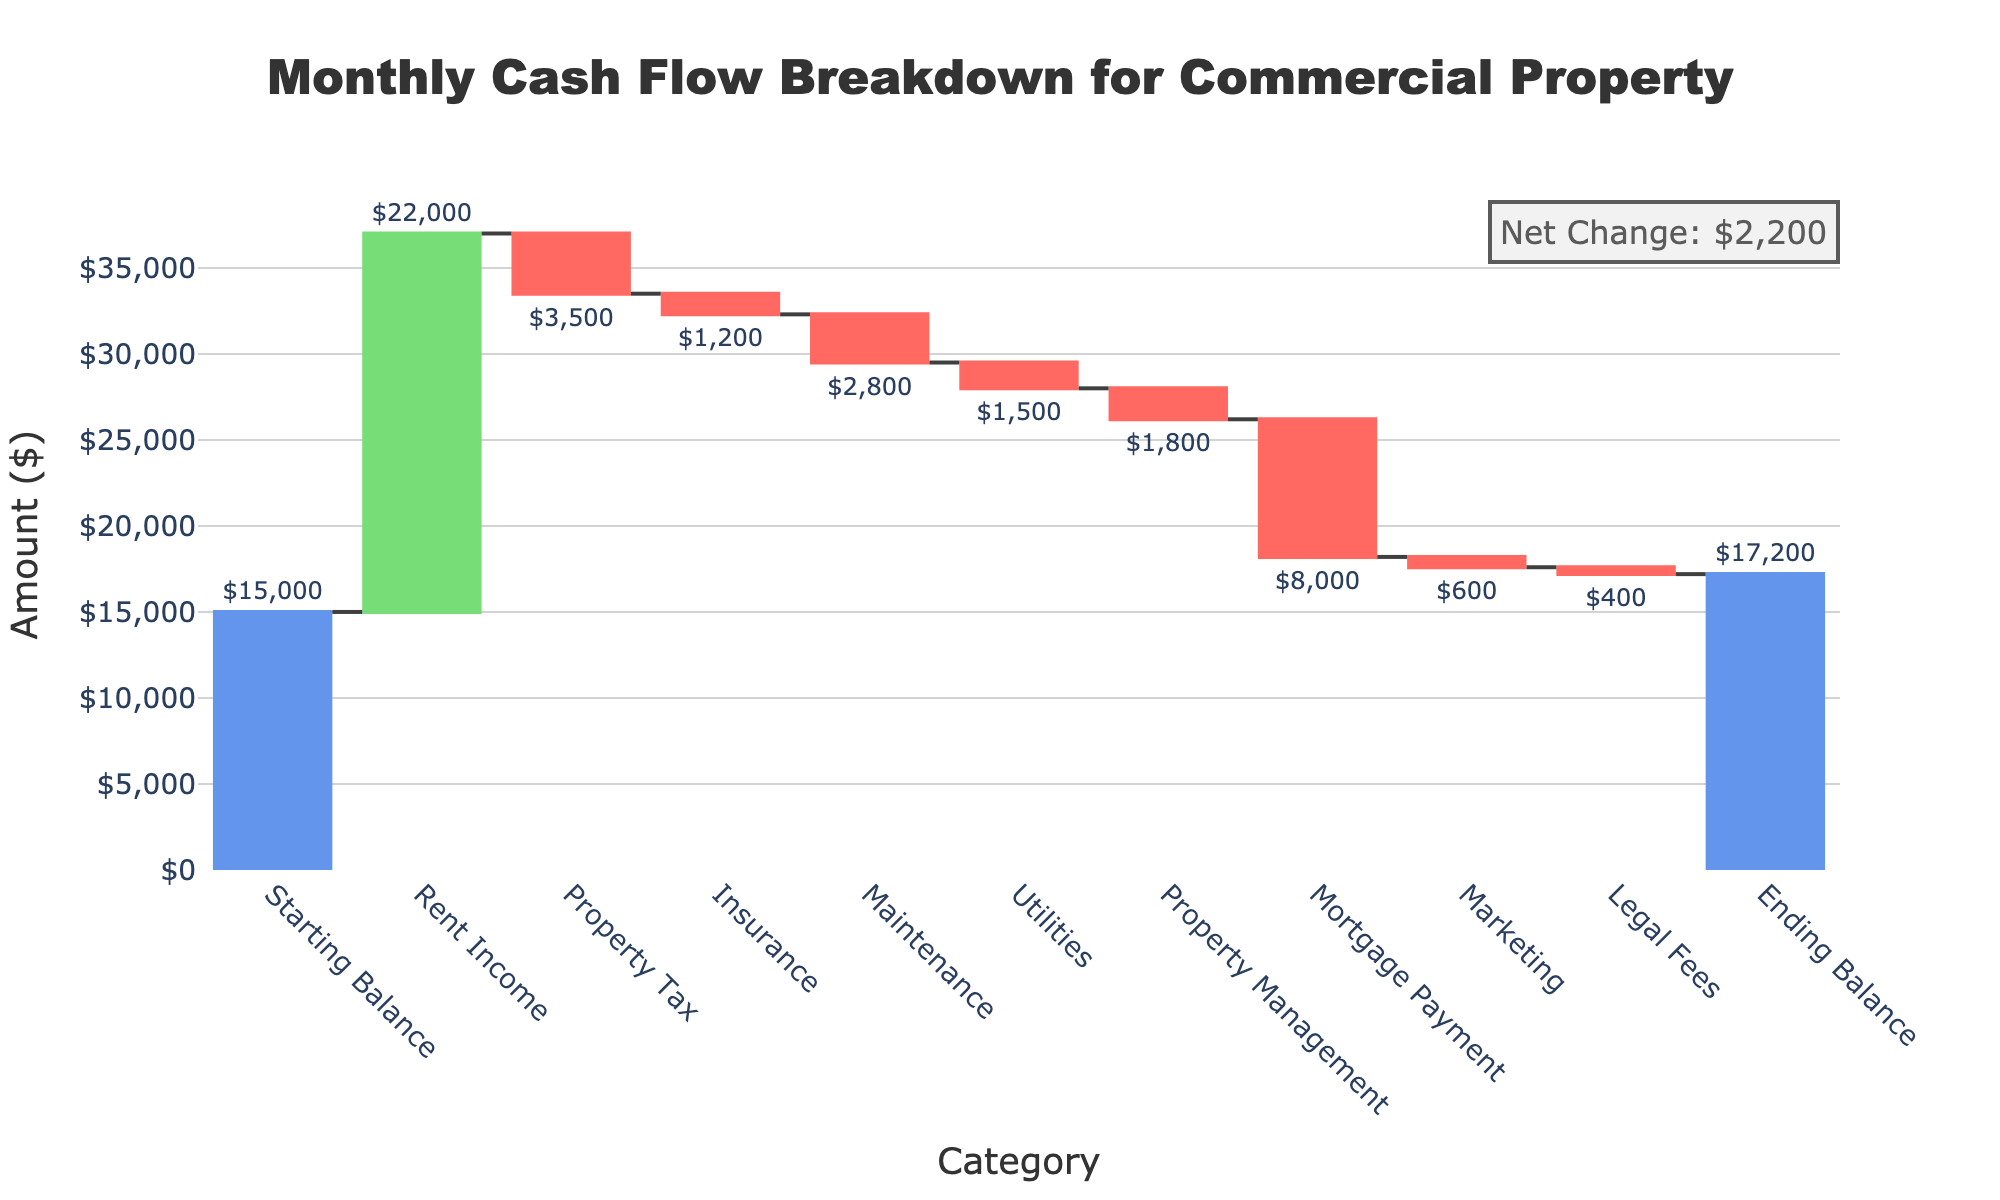What is the title of the chart? The title of the chart is placed at the top and is designed to provide a summary of the content. In this case, it summarizes the chart's focus on the "Monthly Cash Flow Breakdown for Commercial Property".
Answer: Monthly Cash Flow Breakdown for Commercial Property What is the starting balance amount? The starting balance is the first data point in the chart. It is an absolute value and is represented at the beginning of the waterfall. The text label indicates the amount.
Answer: $15,000 Sum up all the income and expenses categories excluding the starting and ending balance. What is the net change? To calculate the net change, sum all income and expense amounts and subtract expenses from income. Income is $22,000 (Rent Income) and the total expenses are $18,800 (Property Tax, Insurance, Maintenance, Utilities, Property Management, Mortgage Payment, Marketing, Legal Fees). Therefore, the net change is $22,000 - $18,800 = $3,200.
Answer: $3,200 What is the ending balance amount, and how is it visually represented? The ending balance is the last data point in the chart. It combines the net changes from the various income and expense categories starting from the initial balance. It's represented as a total value and is visually distinct with a different color marking.
Answer: $17,200 Which category has the highest expense and what is its amount? The highest expense can be identified by comparing the negative values for each expense category. The Mortgage Payment has the largest negative bar. The text label indicates the amount.
Answer: Mortgage Payment, $8,000 Compare the rent income and the property management expense. Look at the bars corresponding to Rent Income and Property Management. The Rent Income bar is significantly higher, indicating a larger amount. Rent Income is $22,000, while Property Management is $1,800.
Answer: Rent Income is $22,000, Property Management is $1,800 Calculate the combined total of Maintenance and Utilities expenses. Add the amounts of Maintenance and Utilities. Maintenance is $2,800, and Utilities is $1,500. So the total is $2,800 + $1,500 = $4,300.
Answer: $4,300 What color is used to represent increasing and decreasing values, and why is this distinction important? Increasing values like income are shown in green, while decreasing values like expenses are shown in red. This color distinction helps viewers quickly differentiate between income and expenses, aiding in the overall readability and understanding of the cash flow.
Answer: Green for increasing, Red for decreasing How does the net change annotation help in understanding the chart? The net change annotation provides a quick reference that summarizes the difference between the starting and ending balances, emphasizing the overall change without needing to trace through all individual bars. It highlights the final impact of all income and expenses combined.
Answer: It shows the overall change from the starting to the ending balance 